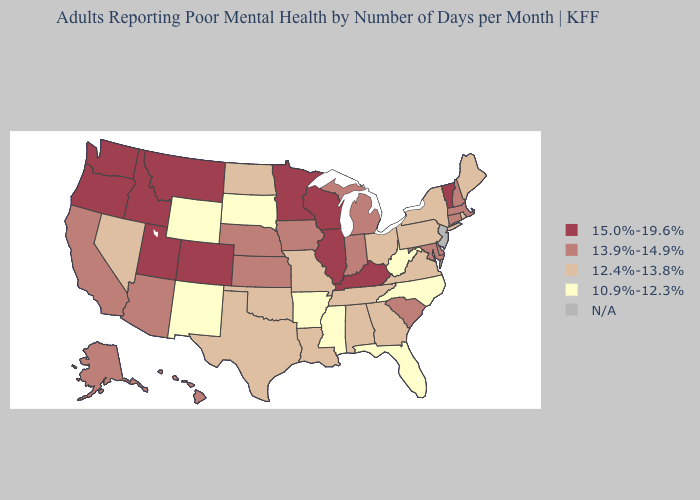Does Maryland have the lowest value in the USA?
Answer briefly. No. How many symbols are there in the legend?
Be succinct. 5. Name the states that have a value in the range 12.4%-13.8%?
Be succinct. Alabama, Georgia, Louisiana, Maine, Missouri, Nevada, New York, North Dakota, Ohio, Oklahoma, Pennsylvania, Rhode Island, Tennessee, Texas, Virginia. Name the states that have a value in the range 12.4%-13.8%?
Answer briefly. Alabama, Georgia, Louisiana, Maine, Missouri, Nevada, New York, North Dakota, Ohio, Oklahoma, Pennsylvania, Rhode Island, Tennessee, Texas, Virginia. Which states have the lowest value in the USA?
Keep it brief. Arkansas, Florida, Mississippi, New Mexico, North Carolina, South Dakota, West Virginia, Wyoming. What is the lowest value in the West?
Write a very short answer. 10.9%-12.3%. What is the value of Missouri?
Quick response, please. 12.4%-13.8%. What is the highest value in the South ?
Keep it brief. 15.0%-19.6%. What is the highest value in the USA?
Write a very short answer. 15.0%-19.6%. What is the value of Michigan?
Write a very short answer. 13.9%-14.9%. Which states have the lowest value in the USA?
Short answer required. Arkansas, Florida, Mississippi, New Mexico, North Carolina, South Dakota, West Virginia, Wyoming. Does the map have missing data?
Quick response, please. Yes. Does New Mexico have the highest value in the USA?
Write a very short answer. No. Which states hav the highest value in the Northeast?
Keep it brief. Vermont. What is the highest value in states that border Minnesota?
Be succinct. 15.0%-19.6%. 